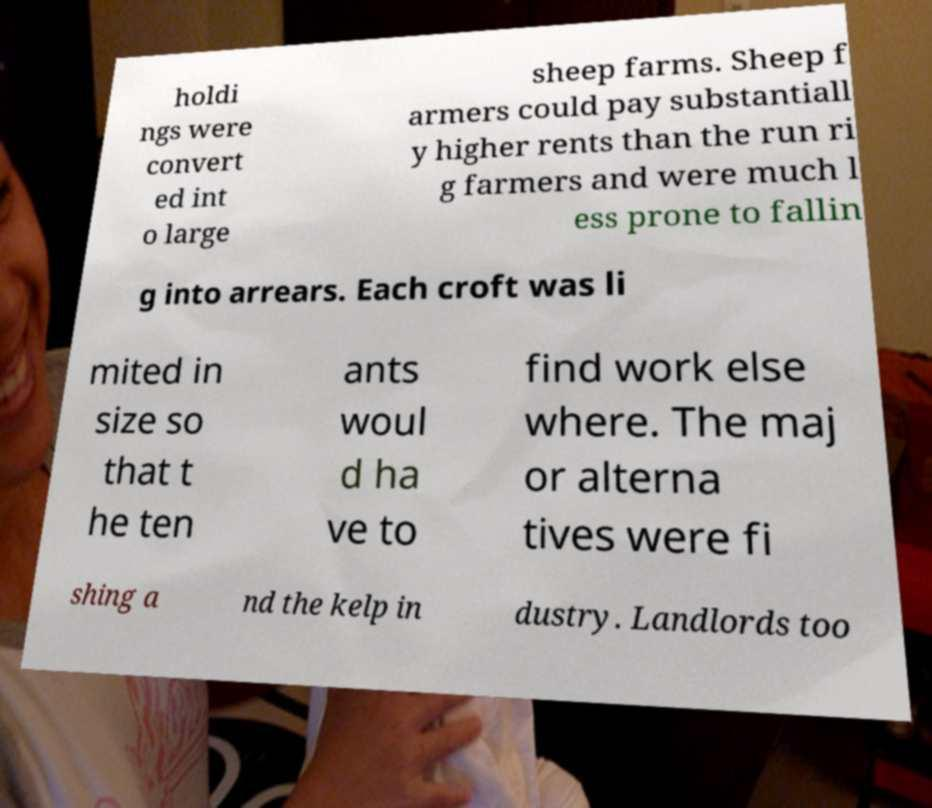Can you accurately transcribe the text from the provided image for me? holdi ngs were convert ed int o large sheep farms. Sheep f armers could pay substantiall y higher rents than the run ri g farmers and were much l ess prone to fallin g into arrears. Each croft was li mited in size so that t he ten ants woul d ha ve to find work else where. The maj or alterna tives were fi shing a nd the kelp in dustry. Landlords too 